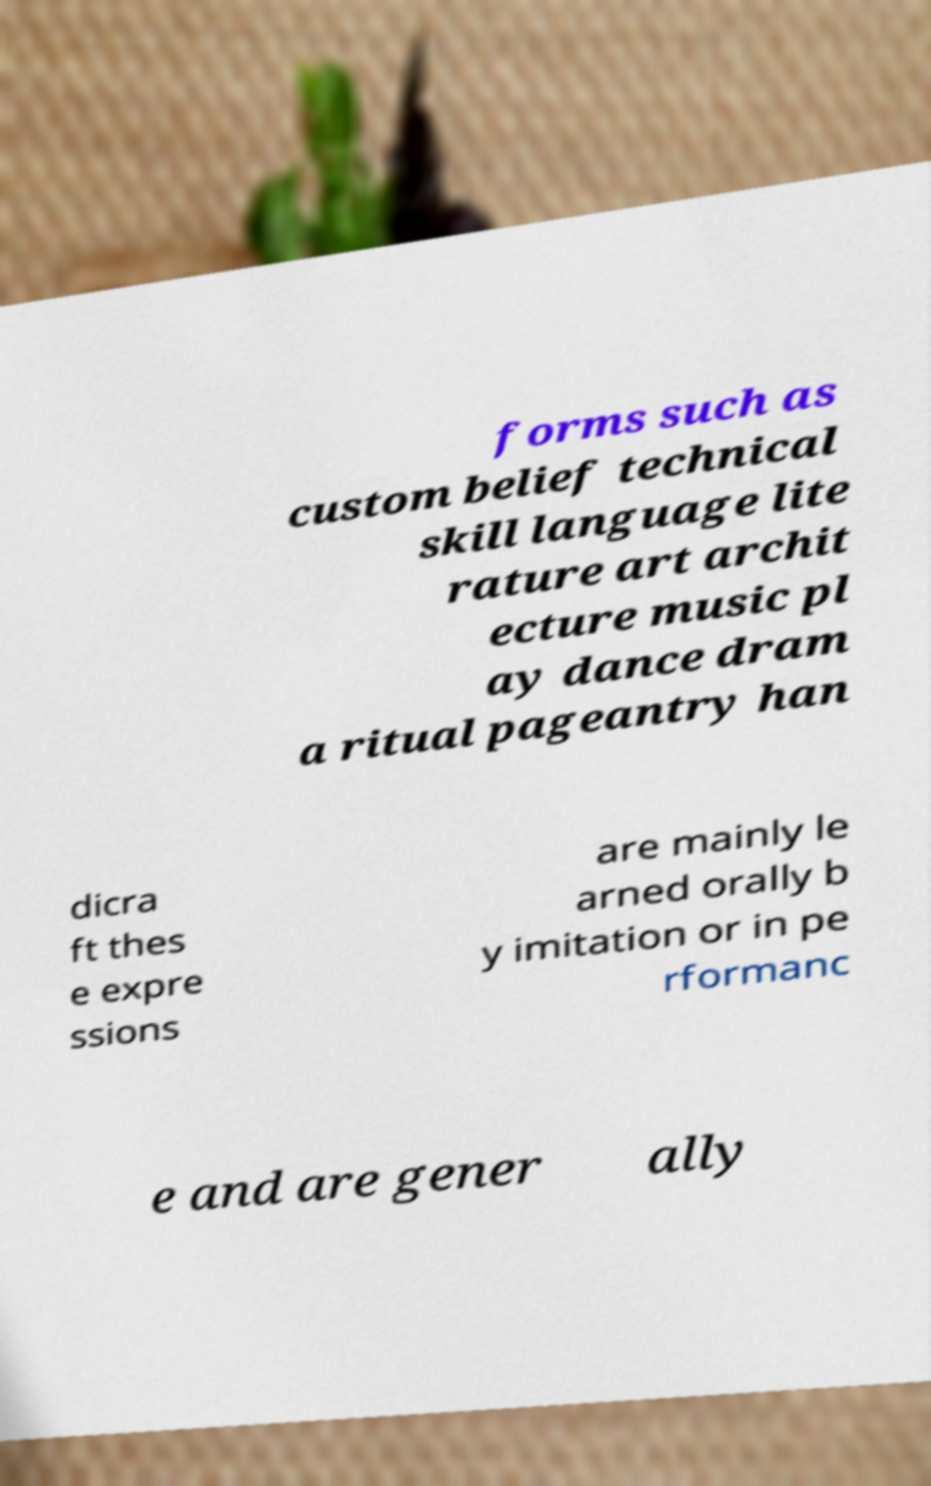Could you extract and type out the text from this image? forms such as custom belief technical skill language lite rature art archit ecture music pl ay dance dram a ritual pageantry han dicra ft thes e expre ssions are mainly le arned orally b y imitation or in pe rformanc e and are gener ally 